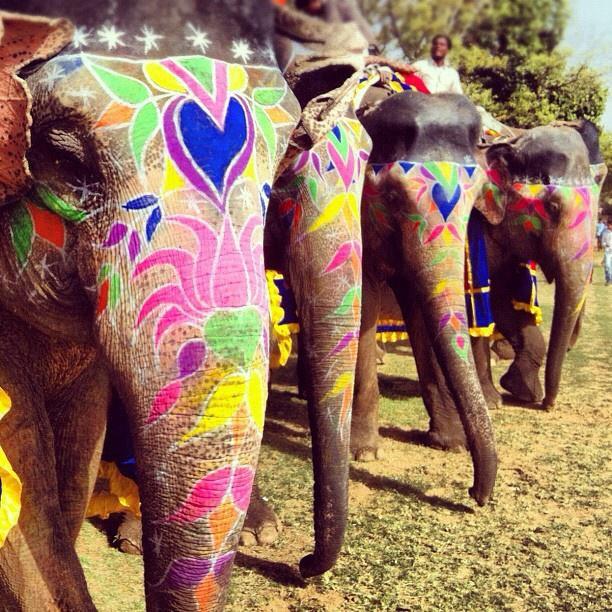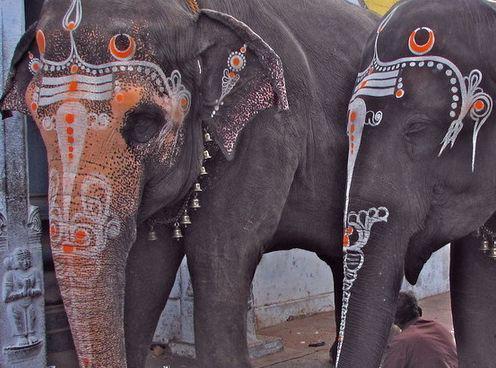The first image is the image on the left, the second image is the image on the right. Assess this claim about the two images: "An image shows a camera-facing tusked elephant wearing an ornate dimensional metallic-look head covering.". Correct or not? Answer yes or no. No. The first image is the image on the left, the second image is the image on the right. For the images shown, is this caption "At least one person is standing near an elephant in the image on the right." true? Answer yes or no. No. The first image is the image on the left, the second image is the image on the right. Analyze the images presented: Is the assertion "An elephant in one image is wearing a colorful head cloth that descends over its forehead to a point between its eyes, so that its eyes are still visible" valid? Answer yes or no. No. The first image is the image on the left, the second image is the image on the right. Assess this claim about the two images: "One elephant wears primarily orange decorations and has something trimmed with bell shapes around its neck.". Correct or not? Answer yes or no. Yes. 